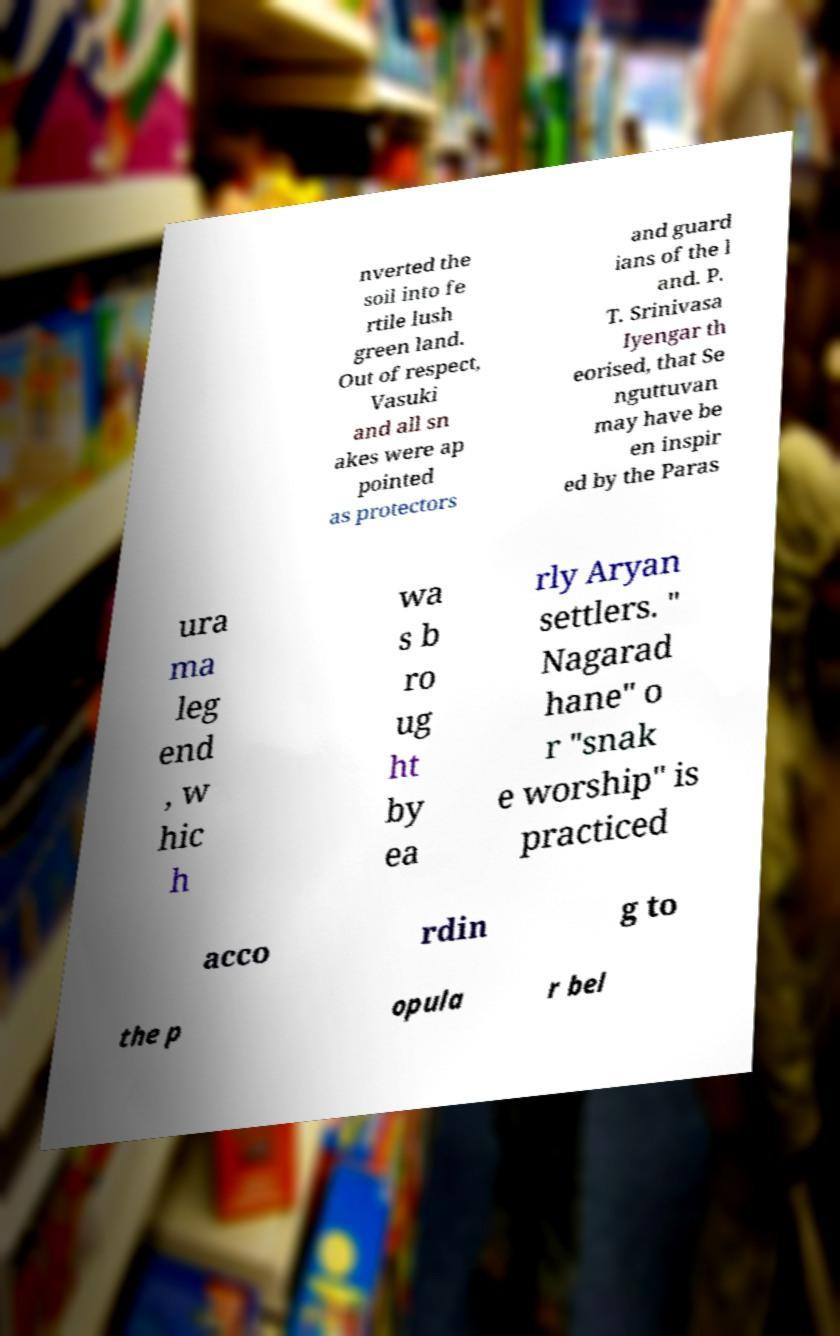Can you accurately transcribe the text from the provided image for me? nverted the soil into fe rtile lush green land. Out of respect, Vasuki and all sn akes were ap pointed as protectors and guard ians of the l and. P. T. Srinivasa Iyengar th eorised, that Se nguttuvan may have be en inspir ed by the Paras ura ma leg end , w hic h wa s b ro ug ht by ea rly Aryan settlers. " Nagarad hane" o r "snak e worship" is practiced acco rdin g to the p opula r bel 